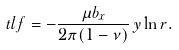<formula> <loc_0><loc_0><loc_500><loc_500>\ t l f = - \frac { \mu b _ { x } } { 2 \pi ( 1 - \nu ) } \, y \ln r .</formula> 